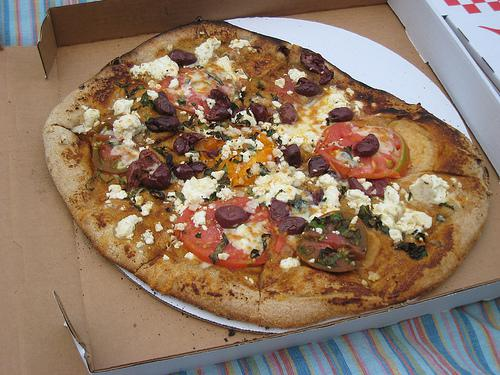Question: where are the olives?
Choices:
A. In the jar.
B. On the plate.
C. On top of the pizza.
D. On the bread.
Answer with the letter. Answer: C Question: what pattern is on the table cloth?
Choices:
A. Stripes.
B. Checks.
C. Circles.
D. Plaid.
Answer with the letter. Answer: A Question: what food is pictured?
Choices:
A. Pizza.
B. Pasta.
C. Tacos.
D. Burritos.
Answer with the letter. Answer: A Question: where is the pizza?
Choices:
A. On the plate.
B. In the box.
C. On the napkin.
D. In the fridge.
Answer with the letter. Answer: B Question: what is the box made out of?
Choices:
A. Glass.
B. Wood.
C. Cardboard.
D. Styrofoam.
Answer with the letter. Answer: C Question: what is the box sitting on?
Choices:
A. The counter.
B. The chair.
C. The table.
D. The shelf.
Answer with the letter. Answer: C 